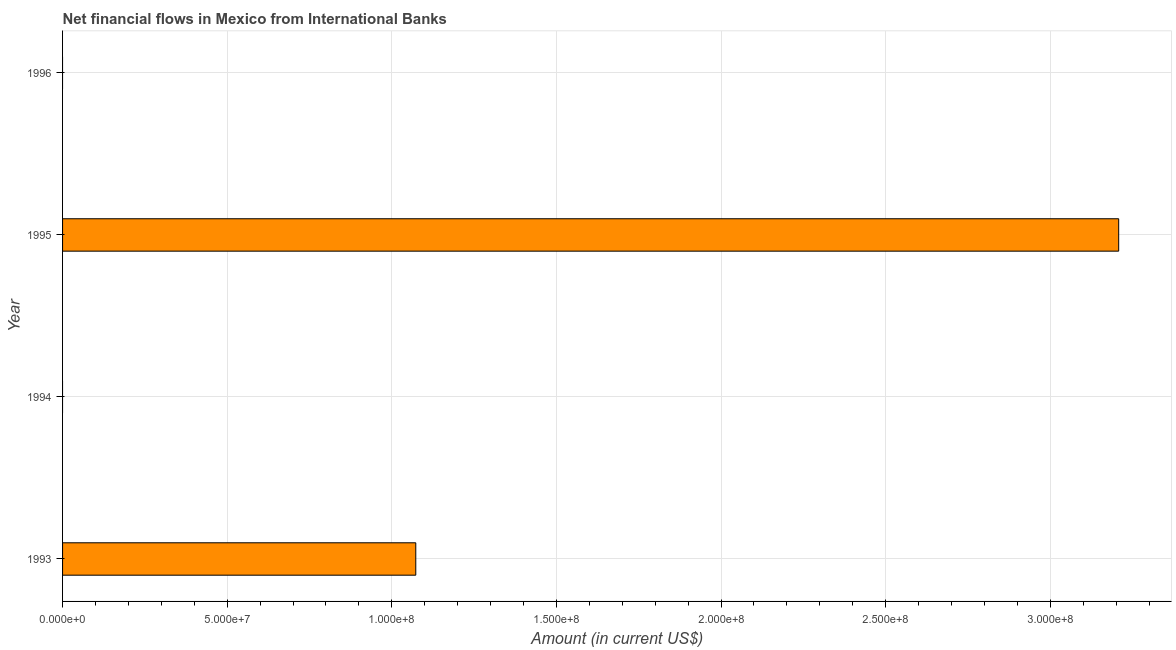Does the graph contain grids?
Your answer should be very brief. Yes. What is the title of the graph?
Offer a terse response. Net financial flows in Mexico from International Banks. What is the label or title of the X-axis?
Your response must be concise. Amount (in current US$). What is the label or title of the Y-axis?
Ensure brevity in your answer.  Year. Across all years, what is the maximum net financial flows from ibrd?
Your response must be concise. 3.21e+08. In which year was the net financial flows from ibrd maximum?
Provide a succinct answer. 1995. What is the sum of the net financial flows from ibrd?
Provide a succinct answer. 4.28e+08. What is the difference between the net financial flows from ibrd in 1993 and 1995?
Your response must be concise. -2.13e+08. What is the average net financial flows from ibrd per year?
Your answer should be compact. 1.07e+08. What is the median net financial flows from ibrd?
Offer a very short reply. 5.36e+07. What is the ratio of the net financial flows from ibrd in 1993 to that in 1995?
Keep it short and to the point. 0.33. What is the difference between the highest and the lowest net financial flows from ibrd?
Give a very brief answer. 3.21e+08. What is the difference between two consecutive major ticks on the X-axis?
Give a very brief answer. 5.00e+07. Are the values on the major ticks of X-axis written in scientific E-notation?
Ensure brevity in your answer.  Yes. What is the Amount (in current US$) in 1993?
Make the answer very short. 1.07e+08. What is the Amount (in current US$) of 1994?
Offer a terse response. 0. What is the Amount (in current US$) in 1995?
Provide a short and direct response. 3.21e+08. What is the difference between the Amount (in current US$) in 1993 and 1995?
Keep it short and to the point. -2.13e+08. What is the ratio of the Amount (in current US$) in 1993 to that in 1995?
Your response must be concise. 0.33. 